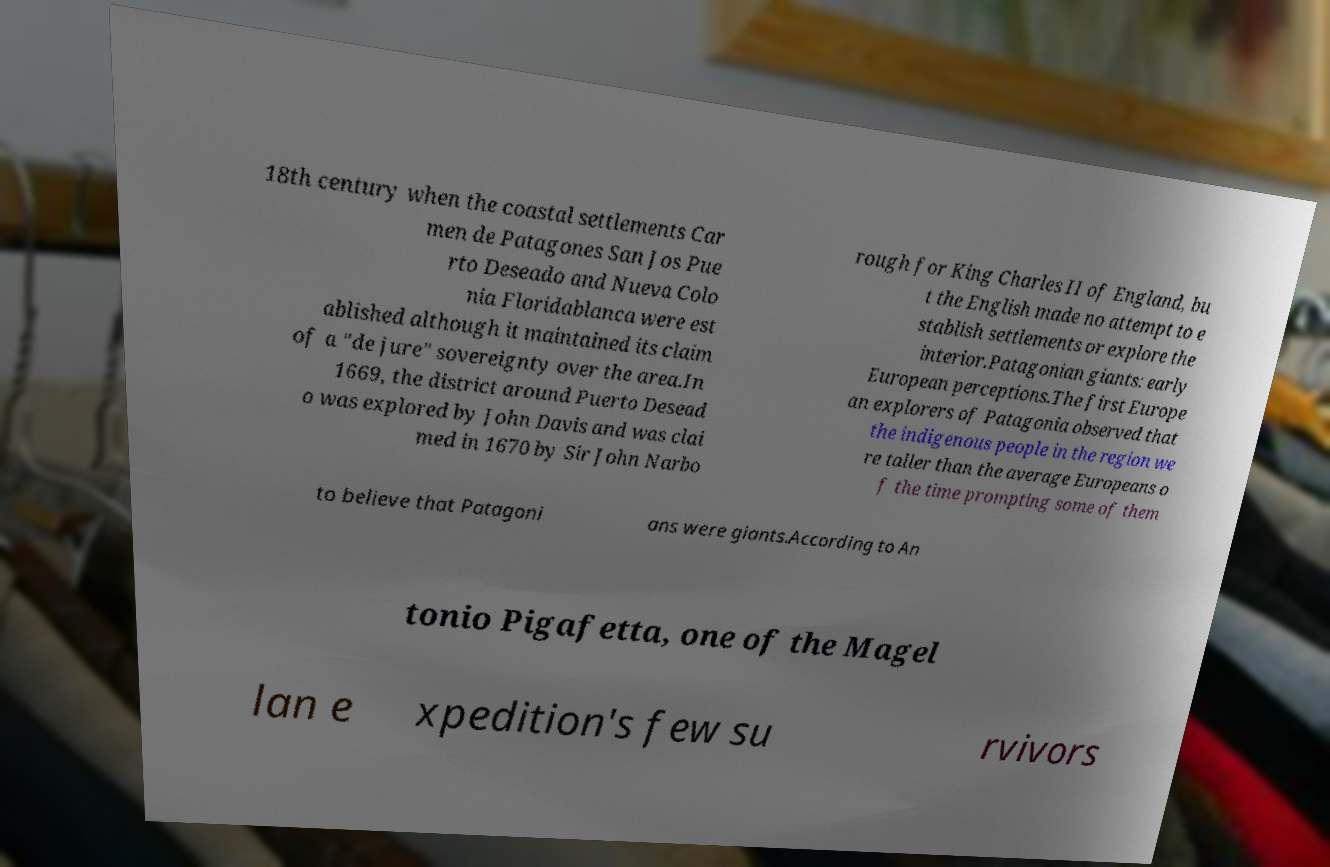What messages or text are displayed in this image? I need them in a readable, typed format. 18th century when the coastal settlements Car men de Patagones San Jos Pue rto Deseado and Nueva Colo nia Floridablanca were est ablished although it maintained its claim of a "de jure" sovereignty over the area.In 1669, the district around Puerto Desead o was explored by John Davis and was clai med in 1670 by Sir John Narbo rough for King Charles II of England, bu t the English made no attempt to e stablish settlements or explore the interior.Patagonian giants: early European perceptions.The first Europe an explorers of Patagonia observed that the indigenous people in the region we re taller than the average Europeans o f the time prompting some of them to believe that Patagoni ans were giants.According to An tonio Pigafetta, one of the Magel lan e xpedition's few su rvivors 